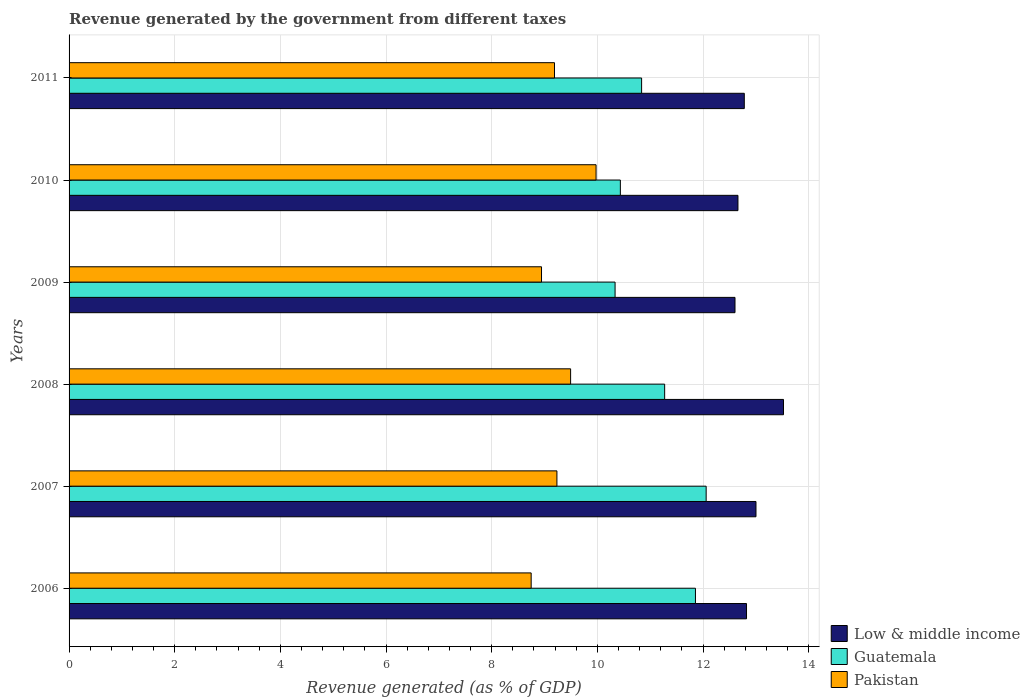How many bars are there on the 1st tick from the top?
Make the answer very short. 3. What is the revenue generated by the government in Low & middle income in 2009?
Keep it short and to the point. 12.61. Across all years, what is the maximum revenue generated by the government in Low & middle income?
Provide a succinct answer. 13.52. Across all years, what is the minimum revenue generated by the government in Pakistan?
Your answer should be very brief. 8.75. What is the total revenue generated by the government in Low & middle income in the graph?
Make the answer very short. 77.4. What is the difference between the revenue generated by the government in Low & middle income in 2006 and that in 2008?
Your answer should be compact. -0.7. What is the difference between the revenue generated by the government in Low & middle income in 2009 and the revenue generated by the government in Guatemala in 2011?
Your answer should be very brief. 1.77. What is the average revenue generated by the government in Guatemala per year?
Offer a very short reply. 11.13. In the year 2011, what is the difference between the revenue generated by the government in Pakistan and revenue generated by the government in Guatemala?
Offer a terse response. -1.65. What is the ratio of the revenue generated by the government in Low & middle income in 2007 to that in 2009?
Your answer should be very brief. 1.03. Is the revenue generated by the government in Low & middle income in 2007 less than that in 2009?
Your response must be concise. No. Is the difference between the revenue generated by the government in Pakistan in 2006 and 2008 greater than the difference between the revenue generated by the government in Guatemala in 2006 and 2008?
Provide a short and direct response. No. What is the difference between the highest and the second highest revenue generated by the government in Guatemala?
Your answer should be very brief. 0.2. What is the difference between the highest and the lowest revenue generated by the government in Guatemala?
Ensure brevity in your answer.  1.72. In how many years, is the revenue generated by the government in Guatemala greater than the average revenue generated by the government in Guatemala taken over all years?
Your answer should be very brief. 3. Is the sum of the revenue generated by the government in Low & middle income in 2007 and 2009 greater than the maximum revenue generated by the government in Guatemala across all years?
Your answer should be compact. Yes. What does the 2nd bar from the top in 2006 represents?
Your answer should be very brief. Guatemala. What does the 2nd bar from the bottom in 2006 represents?
Offer a very short reply. Guatemala. Is it the case that in every year, the sum of the revenue generated by the government in Pakistan and revenue generated by the government in Guatemala is greater than the revenue generated by the government in Low & middle income?
Your answer should be compact. Yes. Are all the bars in the graph horizontal?
Your answer should be compact. Yes. How many years are there in the graph?
Ensure brevity in your answer.  6. What is the difference between two consecutive major ticks on the X-axis?
Ensure brevity in your answer.  2. Does the graph contain grids?
Your answer should be compact. Yes. Where does the legend appear in the graph?
Provide a short and direct response. Bottom right. How many legend labels are there?
Your answer should be very brief. 3. What is the title of the graph?
Offer a very short reply. Revenue generated by the government from different taxes. What is the label or title of the X-axis?
Give a very brief answer. Revenue generated (as % of GDP). What is the Revenue generated (as % of GDP) of Low & middle income in 2006?
Ensure brevity in your answer.  12.82. What is the Revenue generated (as % of GDP) of Guatemala in 2006?
Make the answer very short. 11.86. What is the Revenue generated (as % of GDP) in Pakistan in 2006?
Offer a terse response. 8.75. What is the Revenue generated (as % of GDP) in Low & middle income in 2007?
Keep it short and to the point. 13. What is the Revenue generated (as % of GDP) of Guatemala in 2007?
Provide a succinct answer. 12.06. What is the Revenue generated (as % of GDP) of Pakistan in 2007?
Ensure brevity in your answer.  9.23. What is the Revenue generated (as % of GDP) of Low & middle income in 2008?
Your answer should be very brief. 13.52. What is the Revenue generated (as % of GDP) of Guatemala in 2008?
Make the answer very short. 11.27. What is the Revenue generated (as % of GDP) of Pakistan in 2008?
Your answer should be compact. 9.49. What is the Revenue generated (as % of GDP) of Low & middle income in 2009?
Give a very brief answer. 12.61. What is the Revenue generated (as % of GDP) of Guatemala in 2009?
Keep it short and to the point. 10.34. What is the Revenue generated (as % of GDP) in Pakistan in 2009?
Offer a terse response. 8.94. What is the Revenue generated (as % of GDP) of Low & middle income in 2010?
Give a very brief answer. 12.66. What is the Revenue generated (as % of GDP) in Guatemala in 2010?
Your response must be concise. 10.44. What is the Revenue generated (as % of GDP) of Pakistan in 2010?
Offer a very short reply. 9.98. What is the Revenue generated (as % of GDP) in Low & middle income in 2011?
Offer a terse response. 12.78. What is the Revenue generated (as % of GDP) in Guatemala in 2011?
Make the answer very short. 10.84. What is the Revenue generated (as % of GDP) of Pakistan in 2011?
Provide a succinct answer. 9.19. Across all years, what is the maximum Revenue generated (as % of GDP) in Low & middle income?
Your answer should be very brief. 13.52. Across all years, what is the maximum Revenue generated (as % of GDP) in Guatemala?
Provide a succinct answer. 12.06. Across all years, what is the maximum Revenue generated (as % of GDP) of Pakistan?
Ensure brevity in your answer.  9.98. Across all years, what is the minimum Revenue generated (as % of GDP) of Low & middle income?
Make the answer very short. 12.61. Across all years, what is the minimum Revenue generated (as % of GDP) in Guatemala?
Your answer should be compact. 10.34. Across all years, what is the minimum Revenue generated (as % of GDP) of Pakistan?
Ensure brevity in your answer.  8.75. What is the total Revenue generated (as % of GDP) of Low & middle income in the graph?
Offer a very short reply. 77.4. What is the total Revenue generated (as % of GDP) of Guatemala in the graph?
Your response must be concise. 66.8. What is the total Revenue generated (as % of GDP) in Pakistan in the graph?
Keep it short and to the point. 55.58. What is the difference between the Revenue generated (as % of GDP) of Low & middle income in 2006 and that in 2007?
Your response must be concise. -0.18. What is the difference between the Revenue generated (as % of GDP) in Guatemala in 2006 and that in 2007?
Your answer should be compact. -0.2. What is the difference between the Revenue generated (as % of GDP) of Pakistan in 2006 and that in 2007?
Make the answer very short. -0.49. What is the difference between the Revenue generated (as % of GDP) of Low & middle income in 2006 and that in 2008?
Offer a terse response. -0.7. What is the difference between the Revenue generated (as % of GDP) in Guatemala in 2006 and that in 2008?
Provide a succinct answer. 0.58. What is the difference between the Revenue generated (as % of GDP) of Pakistan in 2006 and that in 2008?
Your answer should be compact. -0.75. What is the difference between the Revenue generated (as % of GDP) of Low & middle income in 2006 and that in 2009?
Your answer should be compact. 0.22. What is the difference between the Revenue generated (as % of GDP) of Guatemala in 2006 and that in 2009?
Offer a very short reply. 1.52. What is the difference between the Revenue generated (as % of GDP) in Pakistan in 2006 and that in 2009?
Provide a short and direct response. -0.2. What is the difference between the Revenue generated (as % of GDP) of Low & middle income in 2006 and that in 2010?
Your answer should be compact. 0.16. What is the difference between the Revenue generated (as % of GDP) of Guatemala in 2006 and that in 2010?
Make the answer very short. 1.42. What is the difference between the Revenue generated (as % of GDP) of Pakistan in 2006 and that in 2010?
Your response must be concise. -1.23. What is the difference between the Revenue generated (as % of GDP) in Low & middle income in 2006 and that in 2011?
Offer a very short reply. 0.04. What is the difference between the Revenue generated (as % of GDP) of Guatemala in 2006 and that in 2011?
Provide a succinct answer. 1.02. What is the difference between the Revenue generated (as % of GDP) of Pakistan in 2006 and that in 2011?
Provide a succinct answer. -0.44. What is the difference between the Revenue generated (as % of GDP) of Low & middle income in 2007 and that in 2008?
Your response must be concise. -0.52. What is the difference between the Revenue generated (as % of GDP) of Guatemala in 2007 and that in 2008?
Ensure brevity in your answer.  0.79. What is the difference between the Revenue generated (as % of GDP) of Pakistan in 2007 and that in 2008?
Your answer should be compact. -0.26. What is the difference between the Revenue generated (as % of GDP) in Low & middle income in 2007 and that in 2009?
Your response must be concise. 0.4. What is the difference between the Revenue generated (as % of GDP) of Guatemala in 2007 and that in 2009?
Ensure brevity in your answer.  1.72. What is the difference between the Revenue generated (as % of GDP) in Pakistan in 2007 and that in 2009?
Give a very brief answer. 0.29. What is the difference between the Revenue generated (as % of GDP) of Low & middle income in 2007 and that in 2010?
Your answer should be very brief. 0.34. What is the difference between the Revenue generated (as % of GDP) of Guatemala in 2007 and that in 2010?
Provide a succinct answer. 1.62. What is the difference between the Revenue generated (as % of GDP) of Pakistan in 2007 and that in 2010?
Give a very brief answer. -0.74. What is the difference between the Revenue generated (as % of GDP) in Low & middle income in 2007 and that in 2011?
Offer a very short reply. 0.22. What is the difference between the Revenue generated (as % of GDP) of Guatemala in 2007 and that in 2011?
Provide a short and direct response. 1.22. What is the difference between the Revenue generated (as % of GDP) in Pakistan in 2007 and that in 2011?
Offer a very short reply. 0.05. What is the difference between the Revenue generated (as % of GDP) in Low & middle income in 2008 and that in 2009?
Offer a very short reply. 0.92. What is the difference between the Revenue generated (as % of GDP) of Guatemala in 2008 and that in 2009?
Provide a short and direct response. 0.94. What is the difference between the Revenue generated (as % of GDP) in Pakistan in 2008 and that in 2009?
Give a very brief answer. 0.55. What is the difference between the Revenue generated (as % of GDP) of Low & middle income in 2008 and that in 2010?
Your answer should be very brief. 0.86. What is the difference between the Revenue generated (as % of GDP) of Guatemala in 2008 and that in 2010?
Give a very brief answer. 0.84. What is the difference between the Revenue generated (as % of GDP) in Pakistan in 2008 and that in 2010?
Your response must be concise. -0.48. What is the difference between the Revenue generated (as % of GDP) in Low & middle income in 2008 and that in 2011?
Provide a succinct answer. 0.74. What is the difference between the Revenue generated (as % of GDP) in Guatemala in 2008 and that in 2011?
Your answer should be compact. 0.44. What is the difference between the Revenue generated (as % of GDP) of Pakistan in 2008 and that in 2011?
Keep it short and to the point. 0.3. What is the difference between the Revenue generated (as % of GDP) of Low & middle income in 2009 and that in 2010?
Offer a very short reply. -0.06. What is the difference between the Revenue generated (as % of GDP) in Guatemala in 2009 and that in 2010?
Your answer should be very brief. -0.1. What is the difference between the Revenue generated (as % of GDP) in Pakistan in 2009 and that in 2010?
Your response must be concise. -1.03. What is the difference between the Revenue generated (as % of GDP) in Low & middle income in 2009 and that in 2011?
Provide a succinct answer. -0.18. What is the difference between the Revenue generated (as % of GDP) of Guatemala in 2009 and that in 2011?
Provide a short and direct response. -0.5. What is the difference between the Revenue generated (as % of GDP) in Pakistan in 2009 and that in 2011?
Provide a short and direct response. -0.25. What is the difference between the Revenue generated (as % of GDP) of Low & middle income in 2010 and that in 2011?
Your answer should be compact. -0.12. What is the difference between the Revenue generated (as % of GDP) in Guatemala in 2010 and that in 2011?
Your answer should be very brief. -0.4. What is the difference between the Revenue generated (as % of GDP) in Pakistan in 2010 and that in 2011?
Give a very brief answer. 0.79. What is the difference between the Revenue generated (as % of GDP) in Low & middle income in 2006 and the Revenue generated (as % of GDP) in Guatemala in 2007?
Make the answer very short. 0.76. What is the difference between the Revenue generated (as % of GDP) in Low & middle income in 2006 and the Revenue generated (as % of GDP) in Pakistan in 2007?
Your answer should be very brief. 3.59. What is the difference between the Revenue generated (as % of GDP) in Guatemala in 2006 and the Revenue generated (as % of GDP) in Pakistan in 2007?
Ensure brevity in your answer.  2.62. What is the difference between the Revenue generated (as % of GDP) of Low & middle income in 2006 and the Revenue generated (as % of GDP) of Guatemala in 2008?
Your answer should be compact. 1.55. What is the difference between the Revenue generated (as % of GDP) in Low & middle income in 2006 and the Revenue generated (as % of GDP) in Pakistan in 2008?
Offer a terse response. 3.33. What is the difference between the Revenue generated (as % of GDP) of Guatemala in 2006 and the Revenue generated (as % of GDP) of Pakistan in 2008?
Give a very brief answer. 2.36. What is the difference between the Revenue generated (as % of GDP) of Low & middle income in 2006 and the Revenue generated (as % of GDP) of Guatemala in 2009?
Your answer should be very brief. 2.49. What is the difference between the Revenue generated (as % of GDP) in Low & middle income in 2006 and the Revenue generated (as % of GDP) in Pakistan in 2009?
Offer a terse response. 3.88. What is the difference between the Revenue generated (as % of GDP) in Guatemala in 2006 and the Revenue generated (as % of GDP) in Pakistan in 2009?
Your response must be concise. 2.91. What is the difference between the Revenue generated (as % of GDP) in Low & middle income in 2006 and the Revenue generated (as % of GDP) in Guatemala in 2010?
Your answer should be compact. 2.39. What is the difference between the Revenue generated (as % of GDP) of Low & middle income in 2006 and the Revenue generated (as % of GDP) of Pakistan in 2010?
Offer a terse response. 2.85. What is the difference between the Revenue generated (as % of GDP) in Guatemala in 2006 and the Revenue generated (as % of GDP) in Pakistan in 2010?
Make the answer very short. 1.88. What is the difference between the Revenue generated (as % of GDP) in Low & middle income in 2006 and the Revenue generated (as % of GDP) in Guatemala in 2011?
Make the answer very short. 1.99. What is the difference between the Revenue generated (as % of GDP) of Low & middle income in 2006 and the Revenue generated (as % of GDP) of Pakistan in 2011?
Provide a short and direct response. 3.63. What is the difference between the Revenue generated (as % of GDP) in Guatemala in 2006 and the Revenue generated (as % of GDP) in Pakistan in 2011?
Your answer should be very brief. 2.67. What is the difference between the Revenue generated (as % of GDP) in Low & middle income in 2007 and the Revenue generated (as % of GDP) in Guatemala in 2008?
Your response must be concise. 1.73. What is the difference between the Revenue generated (as % of GDP) of Low & middle income in 2007 and the Revenue generated (as % of GDP) of Pakistan in 2008?
Give a very brief answer. 3.51. What is the difference between the Revenue generated (as % of GDP) in Guatemala in 2007 and the Revenue generated (as % of GDP) in Pakistan in 2008?
Provide a short and direct response. 2.57. What is the difference between the Revenue generated (as % of GDP) in Low & middle income in 2007 and the Revenue generated (as % of GDP) in Guatemala in 2009?
Give a very brief answer. 2.67. What is the difference between the Revenue generated (as % of GDP) of Low & middle income in 2007 and the Revenue generated (as % of GDP) of Pakistan in 2009?
Your answer should be very brief. 4.06. What is the difference between the Revenue generated (as % of GDP) of Guatemala in 2007 and the Revenue generated (as % of GDP) of Pakistan in 2009?
Give a very brief answer. 3.12. What is the difference between the Revenue generated (as % of GDP) in Low & middle income in 2007 and the Revenue generated (as % of GDP) in Guatemala in 2010?
Provide a short and direct response. 2.57. What is the difference between the Revenue generated (as % of GDP) in Low & middle income in 2007 and the Revenue generated (as % of GDP) in Pakistan in 2010?
Ensure brevity in your answer.  3.03. What is the difference between the Revenue generated (as % of GDP) in Guatemala in 2007 and the Revenue generated (as % of GDP) in Pakistan in 2010?
Give a very brief answer. 2.08. What is the difference between the Revenue generated (as % of GDP) of Low & middle income in 2007 and the Revenue generated (as % of GDP) of Guatemala in 2011?
Your answer should be very brief. 2.16. What is the difference between the Revenue generated (as % of GDP) of Low & middle income in 2007 and the Revenue generated (as % of GDP) of Pakistan in 2011?
Give a very brief answer. 3.81. What is the difference between the Revenue generated (as % of GDP) of Guatemala in 2007 and the Revenue generated (as % of GDP) of Pakistan in 2011?
Your answer should be very brief. 2.87. What is the difference between the Revenue generated (as % of GDP) of Low & middle income in 2008 and the Revenue generated (as % of GDP) of Guatemala in 2009?
Your answer should be very brief. 3.19. What is the difference between the Revenue generated (as % of GDP) of Low & middle income in 2008 and the Revenue generated (as % of GDP) of Pakistan in 2009?
Provide a short and direct response. 4.58. What is the difference between the Revenue generated (as % of GDP) of Guatemala in 2008 and the Revenue generated (as % of GDP) of Pakistan in 2009?
Offer a very short reply. 2.33. What is the difference between the Revenue generated (as % of GDP) of Low & middle income in 2008 and the Revenue generated (as % of GDP) of Guatemala in 2010?
Provide a short and direct response. 3.09. What is the difference between the Revenue generated (as % of GDP) of Low & middle income in 2008 and the Revenue generated (as % of GDP) of Pakistan in 2010?
Your response must be concise. 3.55. What is the difference between the Revenue generated (as % of GDP) in Guatemala in 2008 and the Revenue generated (as % of GDP) in Pakistan in 2010?
Make the answer very short. 1.3. What is the difference between the Revenue generated (as % of GDP) in Low & middle income in 2008 and the Revenue generated (as % of GDP) in Guatemala in 2011?
Ensure brevity in your answer.  2.69. What is the difference between the Revenue generated (as % of GDP) of Low & middle income in 2008 and the Revenue generated (as % of GDP) of Pakistan in 2011?
Provide a short and direct response. 4.33. What is the difference between the Revenue generated (as % of GDP) in Guatemala in 2008 and the Revenue generated (as % of GDP) in Pakistan in 2011?
Keep it short and to the point. 2.09. What is the difference between the Revenue generated (as % of GDP) in Low & middle income in 2009 and the Revenue generated (as % of GDP) in Guatemala in 2010?
Offer a very short reply. 2.17. What is the difference between the Revenue generated (as % of GDP) in Low & middle income in 2009 and the Revenue generated (as % of GDP) in Pakistan in 2010?
Provide a succinct answer. 2.63. What is the difference between the Revenue generated (as % of GDP) in Guatemala in 2009 and the Revenue generated (as % of GDP) in Pakistan in 2010?
Your response must be concise. 0.36. What is the difference between the Revenue generated (as % of GDP) in Low & middle income in 2009 and the Revenue generated (as % of GDP) in Guatemala in 2011?
Offer a terse response. 1.77. What is the difference between the Revenue generated (as % of GDP) in Low & middle income in 2009 and the Revenue generated (as % of GDP) in Pakistan in 2011?
Your response must be concise. 3.42. What is the difference between the Revenue generated (as % of GDP) of Guatemala in 2009 and the Revenue generated (as % of GDP) of Pakistan in 2011?
Give a very brief answer. 1.15. What is the difference between the Revenue generated (as % of GDP) of Low & middle income in 2010 and the Revenue generated (as % of GDP) of Guatemala in 2011?
Provide a succinct answer. 1.82. What is the difference between the Revenue generated (as % of GDP) of Low & middle income in 2010 and the Revenue generated (as % of GDP) of Pakistan in 2011?
Keep it short and to the point. 3.47. What is the difference between the Revenue generated (as % of GDP) in Guatemala in 2010 and the Revenue generated (as % of GDP) in Pakistan in 2011?
Offer a terse response. 1.25. What is the average Revenue generated (as % of GDP) in Low & middle income per year?
Your answer should be compact. 12.9. What is the average Revenue generated (as % of GDP) of Guatemala per year?
Offer a very short reply. 11.13. What is the average Revenue generated (as % of GDP) in Pakistan per year?
Your response must be concise. 9.26. In the year 2006, what is the difference between the Revenue generated (as % of GDP) in Low & middle income and Revenue generated (as % of GDP) in Guatemala?
Offer a very short reply. 0.97. In the year 2006, what is the difference between the Revenue generated (as % of GDP) of Low & middle income and Revenue generated (as % of GDP) of Pakistan?
Offer a terse response. 4.08. In the year 2006, what is the difference between the Revenue generated (as % of GDP) in Guatemala and Revenue generated (as % of GDP) in Pakistan?
Ensure brevity in your answer.  3.11. In the year 2007, what is the difference between the Revenue generated (as % of GDP) of Low & middle income and Revenue generated (as % of GDP) of Guatemala?
Ensure brevity in your answer.  0.94. In the year 2007, what is the difference between the Revenue generated (as % of GDP) in Low & middle income and Revenue generated (as % of GDP) in Pakistan?
Ensure brevity in your answer.  3.77. In the year 2007, what is the difference between the Revenue generated (as % of GDP) in Guatemala and Revenue generated (as % of GDP) in Pakistan?
Give a very brief answer. 2.82. In the year 2008, what is the difference between the Revenue generated (as % of GDP) of Low & middle income and Revenue generated (as % of GDP) of Guatemala?
Your answer should be very brief. 2.25. In the year 2008, what is the difference between the Revenue generated (as % of GDP) of Low & middle income and Revenue generated (as % of GDP) of Pakistan?
Your answer should be very brief. 4.03. In the year 2008, what is the difference between the Revenue generated (as % of GDP) in Guatemala and Revenue generated (as % of GDP) in Pakistan?
Offer a terse response. 1.78. In the year 2009, what is the difference between the Revenue generated (as % of GDP) of Low & middle income and Revenue generated (as % of GDP) of Guatemala?
Give a very brief answer. 2.27. In the year 2009, what is the difference between the Revenue generated (as % of GDP) of Low & middle income and Revenue generated (as % of GDP) of Pakistan?
Your answer should be very brief. 3.66. In the year 2009, what is the difference between the Revenue generated (as % of GDP) of Guatemala and Revenue generated (as % of GDP) of Pakistan?
Offer a terse response. 1.39. In the year 2010, what is the difference between the Revenue generated (as % of GDP) of Low & middle income and Revenue generated (as % of GDP) of Guatemala?
Your response must be concise. 2.23. In the year 2010, what is the difference between the Revenue generated (as % of GDP) of Low & middle income and Revenue generated (as % of GDP) of Pakistan?
Keep it short and to the point. 2.69. In the year 2010, what is the difference between the Revenue generated (as % of GDP) in Guatemala and Revenue generated (as % of GDP) in Pakistan?
Your answer should be compact. 0.46. In the year 2011, what is the difference between the Revenue generated (as % of GDP) of Low & middle income and Revenue generated (as % of GDP) of Guatemala?
Provide a succinct answer. 1.94. In the year 2011, what is the difference between the Revenue generated (as % of GDP) in Low & middle income and Revenue generated (as % of GDP) in Pakistan?
Ensure brevity in your answer.  3.59. In the year 2011, what is the difference between the Revenue generated (as % of GDP) of Guatemala and Revenue generated (as % of GDP) of Pakistan?
Make the answer very short. 1.65. What is the ratio of the Revenue generated (as % of GDP) in Low & middle income in 2006 to that in 2007?
Make the answer very short. 0.99. What is the ratio of the Revenue generated (as % of GDP) of Guatemala in 2006 to that in 2007?
Your answer should be compact. 0.98. What is the ratio of the Revenue generated (as % of GDP) in Pakistan in 2006 to that in 2007?
Keep it short and to the point. 0.95. What is the ratio of the Revenue generated (as % of GDP) of Low & middle income in 2006 to that in 2008?
Your answer should be very brief. 0.95. What is the ratio of the Revenue generated (as % of GDP) in Guatemala in 2006 to that in 2008?
Provide a short and direct response. 1.05. What is the ratio of the Revenue generated (as % of GDP) in Pakistan in 2006 to that in 2008?
Your answer should be very brief. 0.92. What is the ratio of the Revenue generated (as % of GDP) in Low & middle income in 2006 to that in 2009?
Your answer should be very brief. 1.02. What is the ratio of the Revenue generated (as % of GDP) of Guatemala in 2006 to that in 2009?
Your answer should be compact. 1.15. What is the ratio of the Revenue generated (as % of GDP) of Pakistan in 2006 to that in 2009?
Give a very brief answer. 0.98. What is the ratio of the Revenue generated (as % of GDP) in Low & middle income in 2006 to that in 2010?
Offer a terse response. 1.01. What is the ratio of the Revenue generated (as % of GDP) of Guatemala in 2006 to that in 2010?
Keep it short and to the point. 1.14. What is the ratio of the Revenue generated (as % of GDP) in Pakistan in 2006 to that in 2010?
Offer a very short reply. 0.88. What is the ratio of the Revenue generated (as % of GDP) of Guatemala in 2006 to that in 2011?
Give a very brief answer. 1.09. What is the ratio of the Revenue generated (as % of GDP) of Pakistan in 2006 to that in 2011?
Offer a terse response. 0.95. What is the ratio of the Revenue generated (as % of GDP) of Low & middle income in 2007 to that in 2008?
Keep it short and to the point. 0.96. What is the ratio of the Revenue generated (as % of GDP) in Guatemala in 2007 to that in 2008?
Your response must be concise. 1.07. What is the ratio of the Revenue generated (as % of GDP) of Pakistan in 2007 to that in 2008?
Give a very brief answer. 0.97. What is the ratio of the Revenue generated (as % of GDP) of Low & middle income in 2007 to that in 2009?
Provide a short and direct response. 1.03. What is the ratio of the Revenue generated (as % of GDP) of Guatemala in 2007 to that in 2009?
Your response must be concise. 1.17. What is the ratio of the Revenue generated (as % of GDP) of Pakistan in 2007 to that in 2009?
Provide a succinct answer. 1.03. What is the ratio of the Revenue generated (as % of GDP) in Low & middle income in 2007 to that in 2010?
Your answer should be very brief. 1.03. What is the ratio of the Revenue generated (as % of GDP) of Guatemala in 2007 to that in 2010?
Offer a terse response. 1.16. What is the ratio of the Revenue generated (as % of GDP) in Pakistan in 2007 to that in 2010?
Provide a succinct answer. 0.93. What is the ratio of the Revenue generated (as % of GDP) of Low & middle income in 2007 to that in 2011?
Give a very brief answer. 1.02. What is the ratio of the Revenue generated (as % of GDP) in Guatemala in 2007 to that in 2011?
Your answer should be compact. 1.11. What is the ratio of the Revenue generated (as % of GDP) in Low & middle income in 2008 to that in 2009?
Offer a very short reply. 1.07. What is the ratio of the Revenue generated (as % of GDP) of Guatemala in 2008 to that in 2009?
Provide a short and direct response. 1.09. What is the ratio of the Revenue generated (as % of GDP) of Pakistan in 2008 to that in 2009?
Your response must be concise. 1.06. What is the ratio of the Revenue generated (as % of GDP) in Low & middle income in 2008 to that in 2010?
Your answer should be very brief. 1.07. What is the ratio of the Revenue generated (as % of GDP) of Guatemala in 2008 to that in 2010?
Make the answer very short. 1.08. What is the ratio of the Revenue generated (as % of GDP) in Pakistan in 2008 to that in 2010?
Your response must be concise. 0.95. What is the ratio of the Revenue generated (as % of GDP) in Low & middle income in 2008 to that in 2011?
Provide a succinct answer. 1.06. What is the ratio of the Revenue generated (as % of GDP) in Guatemala in 2008 to that in 2011?
Your response must be concise. 1.04. What is the ratio of the Revenue generated (as % of GDP) of Pakistan in 2008 to that in 2011?
Provide a succinct answer. 1.03. What is the ratio of the Revenue generated (as % of GDP) of Pakistan in 2009 to that in 2010?
Ensure brevity in your answer.  0.9. What is the ratio of the Revenue generated (as % of GDP) of Low & middle income in 2009 to that in 2011?
Offer a very short reply. 0.99. What is the ratio of the Revenue generated (as % of GDP) of Guatemala in 2009 to that in 2011?
Your response must be concise. 0.95. What is the ratio of the Revenue generated (as % of GDP) in Pakistan in 2009 to that in 2011?
Ensure brevity in your answer.  0.97. What is the ratio of the Revenue generated (as % of GDP) of Low & middle income in 2010 to that in 2011?
Your answer should be very brief. 0.99. What is the ratio of the Revenue generated (as % of GDP) in Guatemala in 2010 to that in 2011?
Your answer should be very brief. 0.96. What is the ratio of the Revenue generated (as % of GDP) in Pakistan in 2010 to that in 2011?
Keep it short and to the point. 1.09. What is the difference between the highest and the second highest Revenue generated (as % of GDP) in Low & middle income?
Offer a terse response. 0.52. What is the difference between the highest and the second highest Revenue generated (as % of GDP) in Guatemala?
Make the answer very short. 0.2. What is the difference between the highest and the second highest Revenue generated (as % of GDP) in Pakistan?
Provide a succinct answer. 0.48. What is the difference between the highest and the lowest Revenue generated (as % of GDP) in Low & middle income?
Your answer should be very brief. 0.92. What is the difference between the highest and the lowest Revenue generated (as % of GDP) of Guatemala?
Your answer should be compact. 1.72. What is the difference between the highest and the lowest Revenue generated (as % of GDP) in Pakistan?
Offer a very short reply. 1.23. 